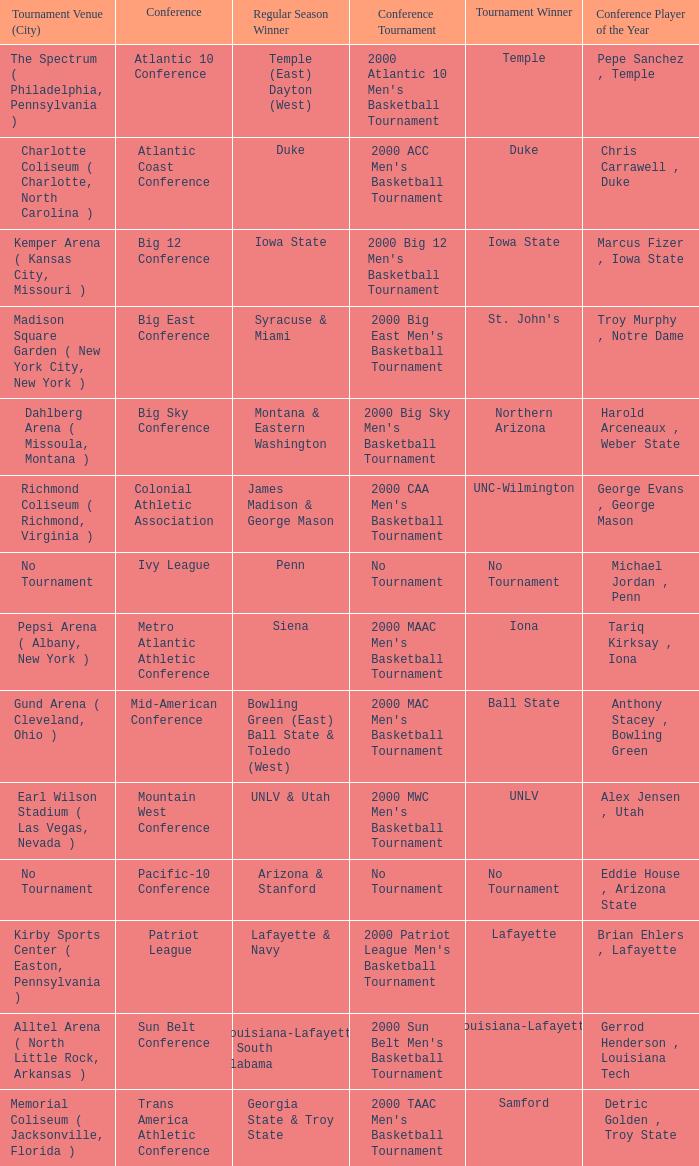Where was the Ivy League conference tournament? No Tournament. 